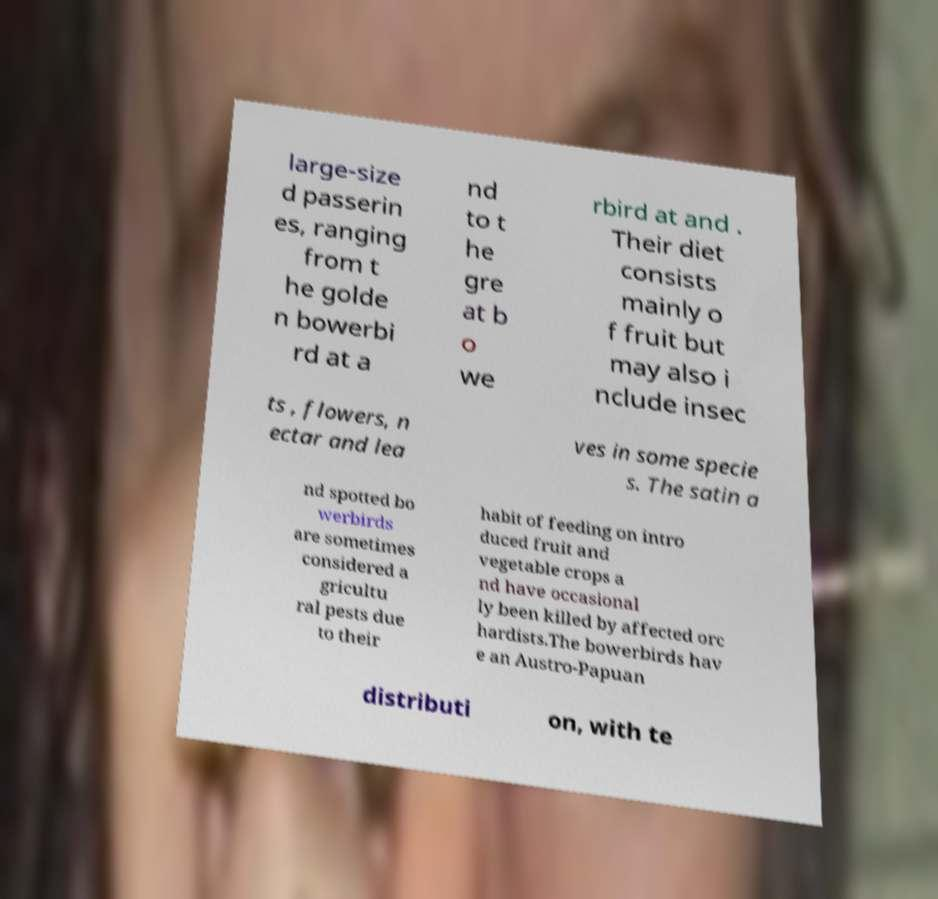For documentation purposes, I need the text within this image transcribed. Could you provide that? large-size d passerin es, ranging from t he golde n bowerbi rd at a nd to t he gre at b o we rbird at and . Their diet consists mainly o f fruit but may also i nclude insec ts , flowers, n ectar and lea ves in some specie s. The satin a nd spotted bo werbirds are sometimes considered a gricultu ral pests due to their habit of feeding on intro duced fruit and vegetable crops a nd have occasional ly been killed by affected orc hardists.The bowerbirds hav e an Austro-Papuan distributi on, with te 